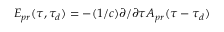<formula> <loc_0><loc_0><loc_500><loc_500>E _ { p r } ( \tau , \tau _ { d } ) = - ( 1 / c ) \partial / \partial \tau A _ { p r } ( \tau - \tau _ { d } )</formula> 